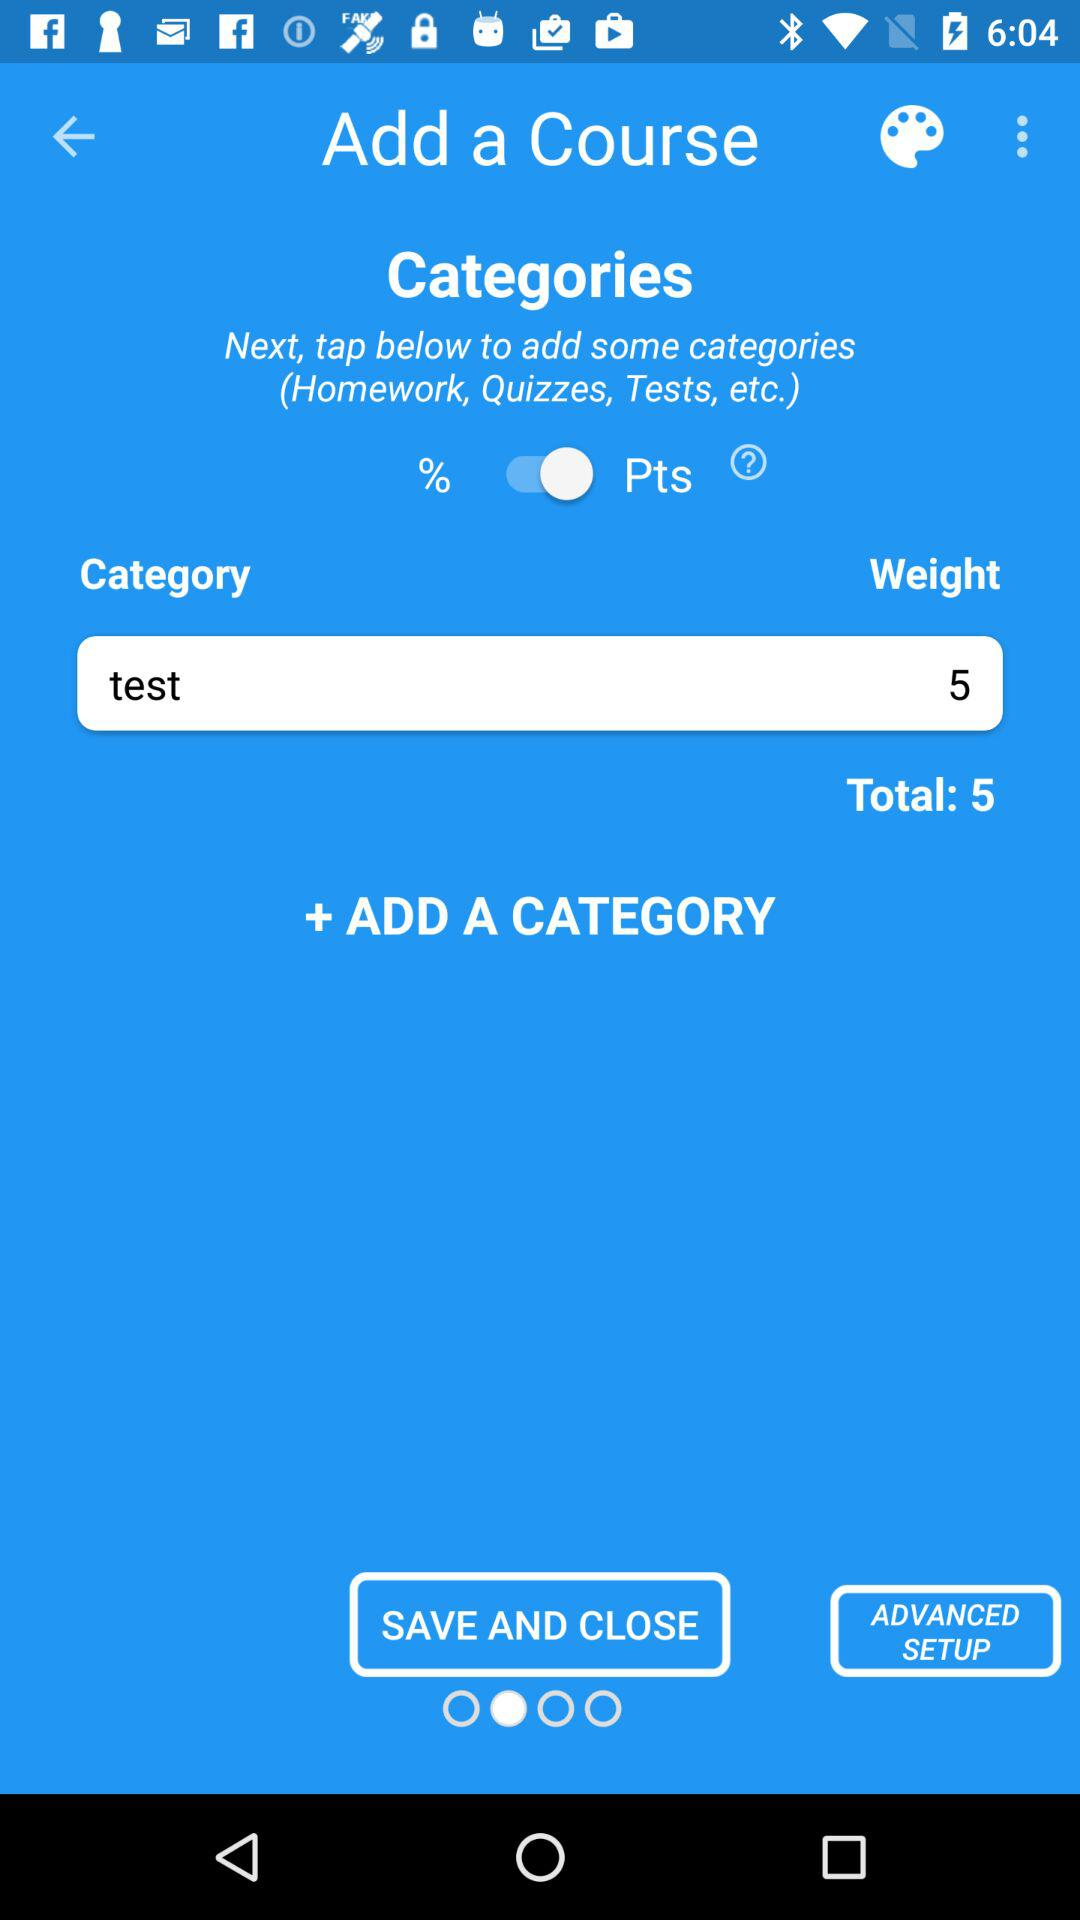What is the mentioned category? The mentioned category is test. 